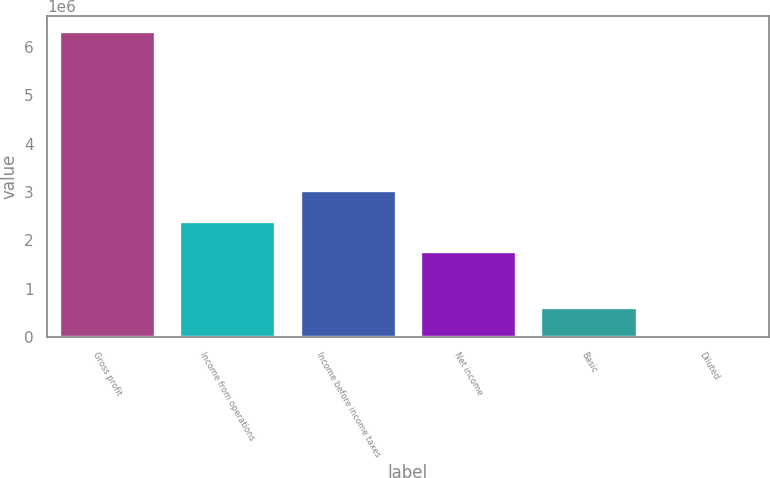<chart> <loc_0><loc_0><loc_500><loc_500><bar_chart><fcel>Gross profit<fcel>Income from operations<fcel>Income before income taxes<fcel>Net income<fcel>Basic<fcel>Diluted<nl><fcel>6.31319e+06<fcel>2.41079e+06<fcel>3.04211e+06<fcel>1.77947e+06<fcel>631320<fcel>1.36<nl></chart> 